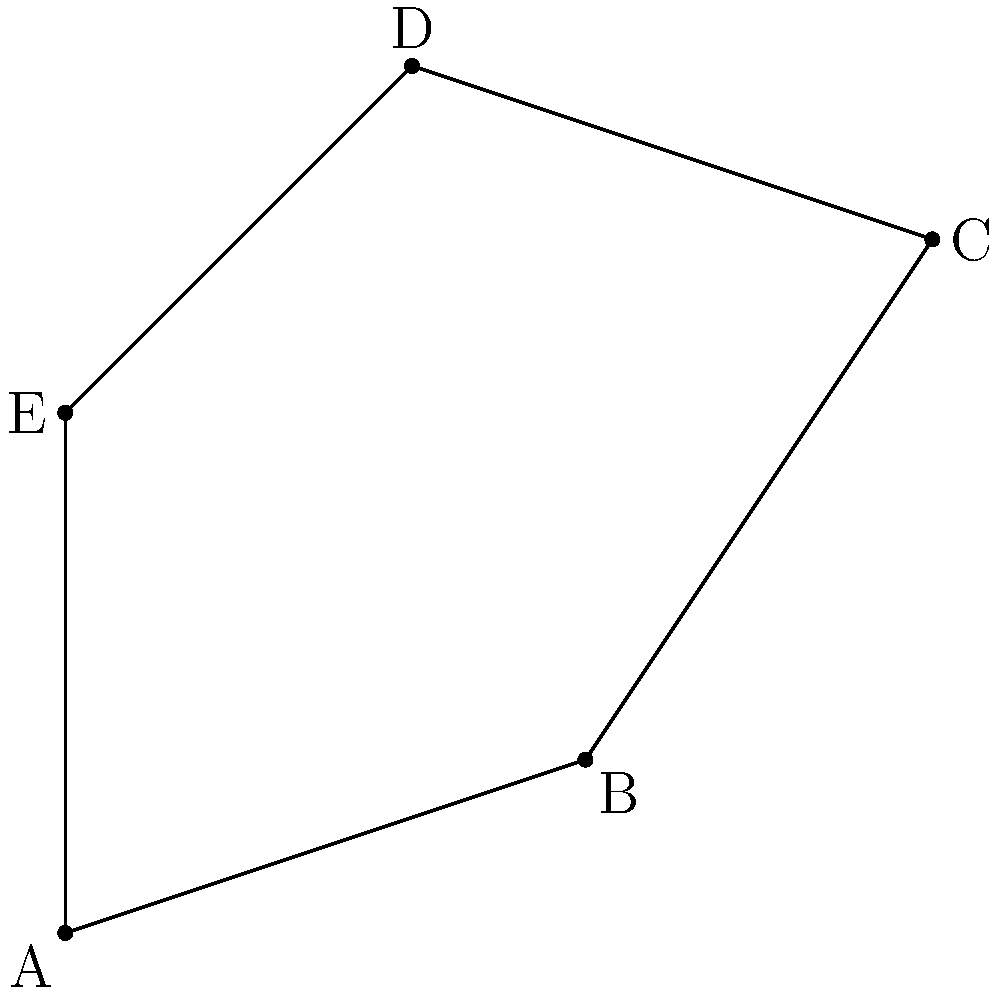As a farmer with an irregularly shaped plot of land near the border, you need to calculate its area for crop planning and potential cross-border agricultural collaborations. Using the topological method of triangulation, determine the area of your farmland plot given by the coordinates A(0,0), B(3,1), C(5,4), D(2,5), and E(0,3) in square kilometers. To calculate the area of this irregular polygon using triangulation:

1. Divide the polygon into three triangles: ABC, ACD, and ADE.

2. Calculate the area of each triangle using the formula:
   Area = $\frac{1}{2}|x_1(y_2 - y_3) + x_2(y_3 - y_1) + x_3(y_1 - y_2)|$

3. For triangle ABC:
   $A_{ABC} = \frac{1}{2}|0(1-4) + 3(4-0) + 5(0-1)| = \frac{1}{2}|12-5| = 3.5$ sq km

4. For triangle ACD:
   $A_{ACD} = \frac{1}{2}|0(5-3) + 5(3-0) + 2(0-5)| = \frac{1}{2}|10-10| = 0$ sq km

5. For triangle ADE:
   $A_{ADE} = \frac{1}{2}|0(5-3) + 2(3-0) + 0(0-5)| = \frac{1}{2}|6| = 3$ sq km

6. Sum the areas of all triangles:
   Total Area = $A_{ABC} + A_{ACD} + A_{ADE} = 3.5 + 0 + 3 = 6.5$ sq km
Answer: 6.5 sq km 